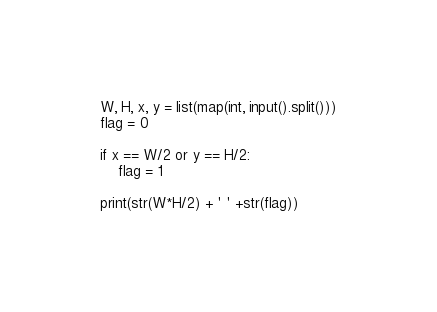Convert code to text. <code><loc_0><loc_0><loc_500><loc_500><_Python_>W, H, x, y = list(map(int, input().split()))
flag = 0

if x == W/2 or y == H/2:
    flag = 1
    
print(str(W*H/2) + ' ' +str(flag))</code> 